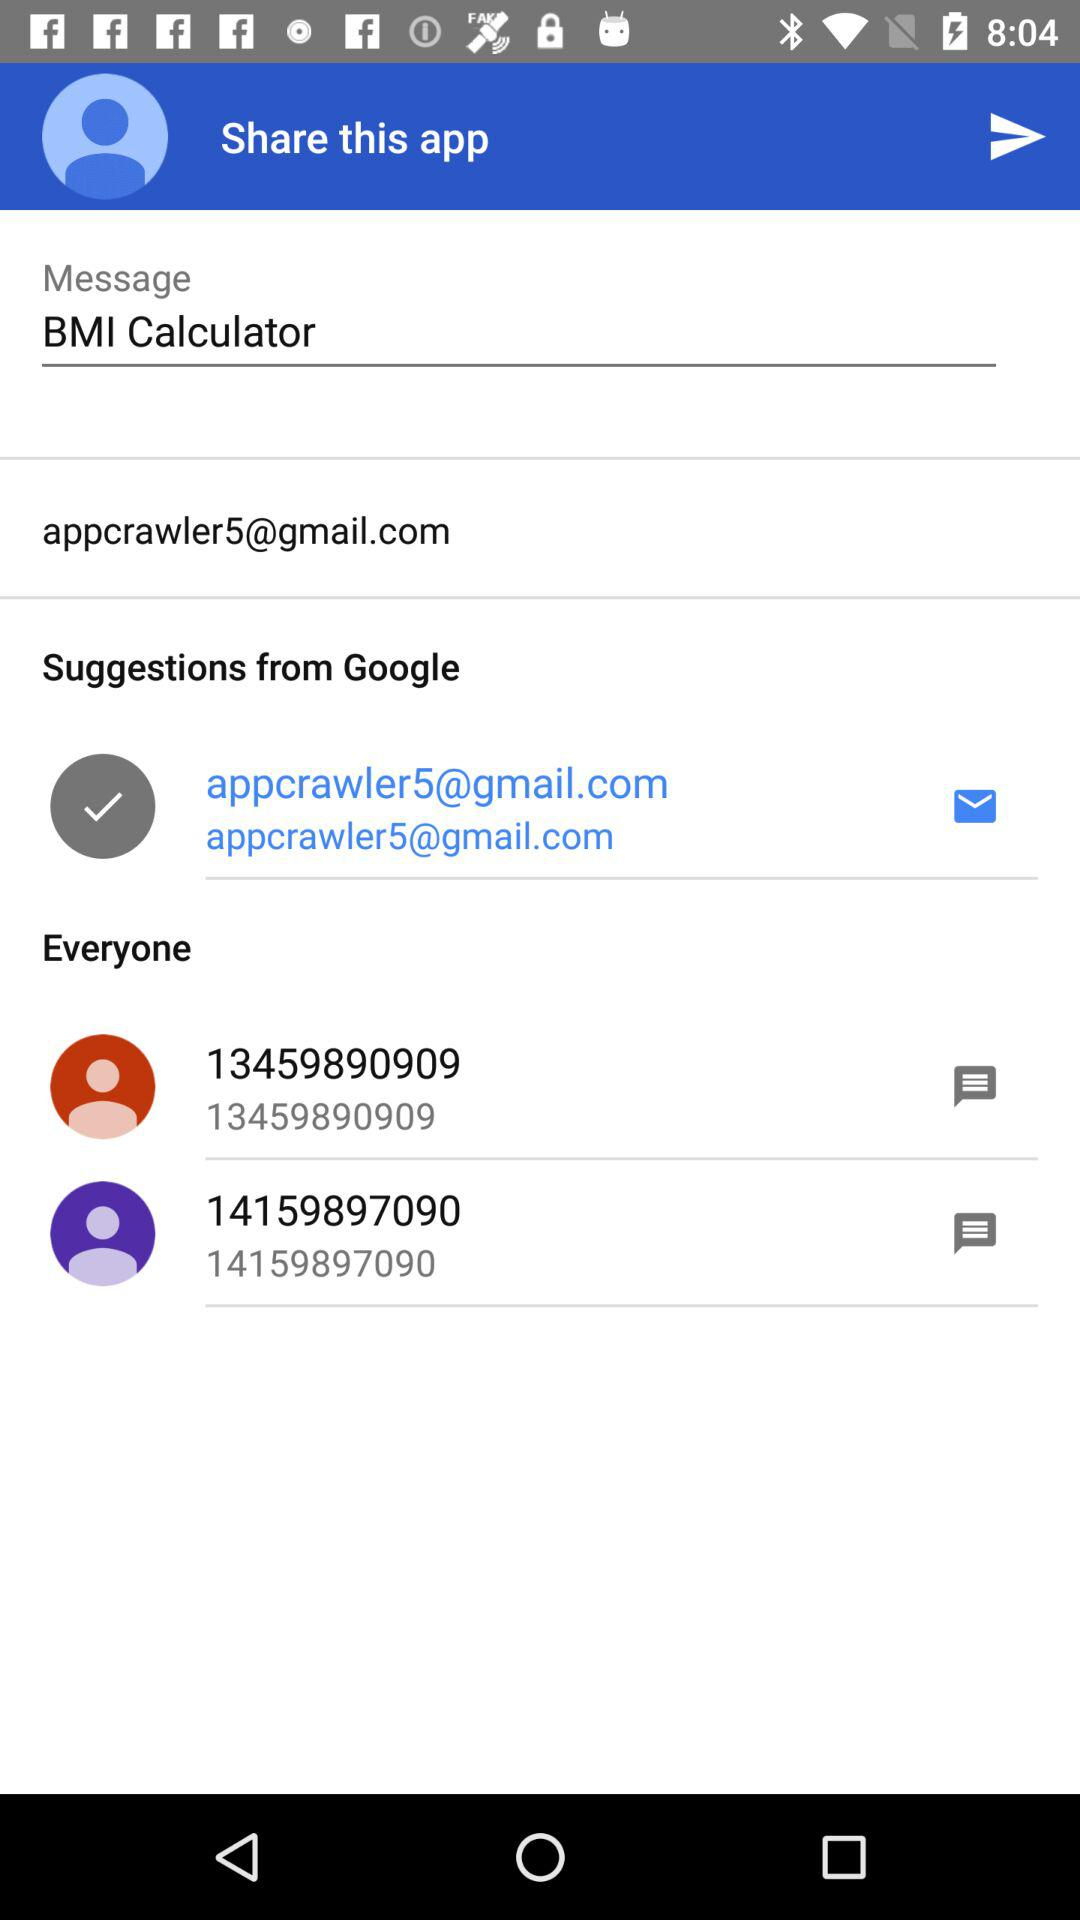What is the email address? The email address is appcrawler5@gmail.com. 